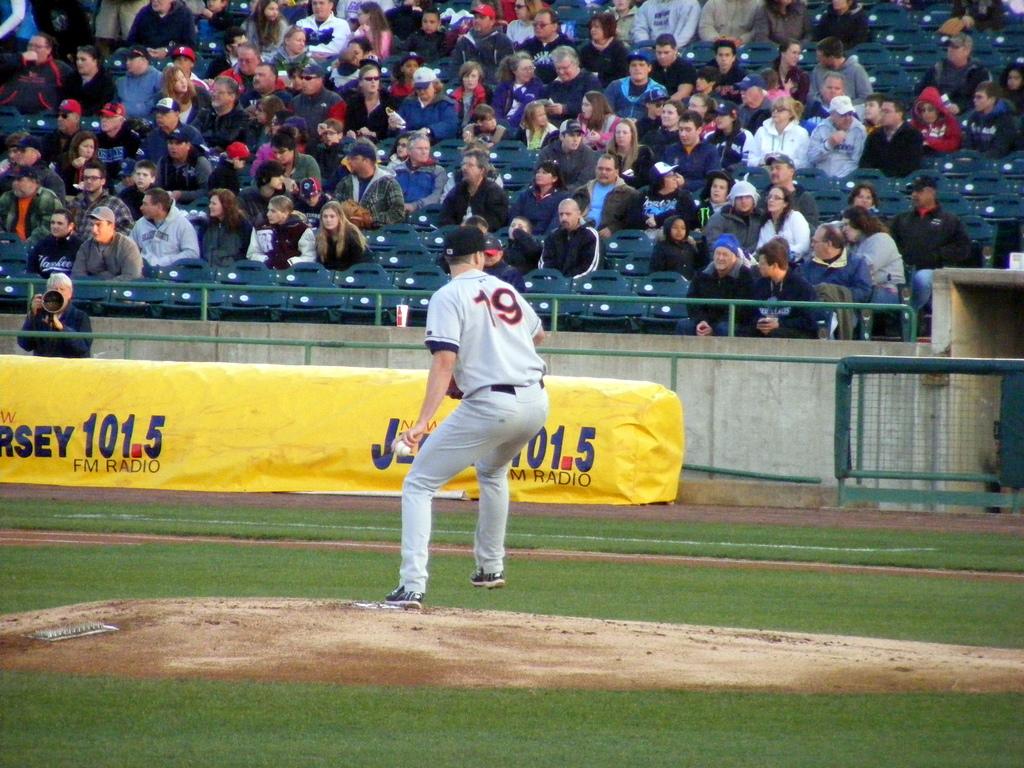What is the baseball players number?
Keep it short and to the point. 19. 